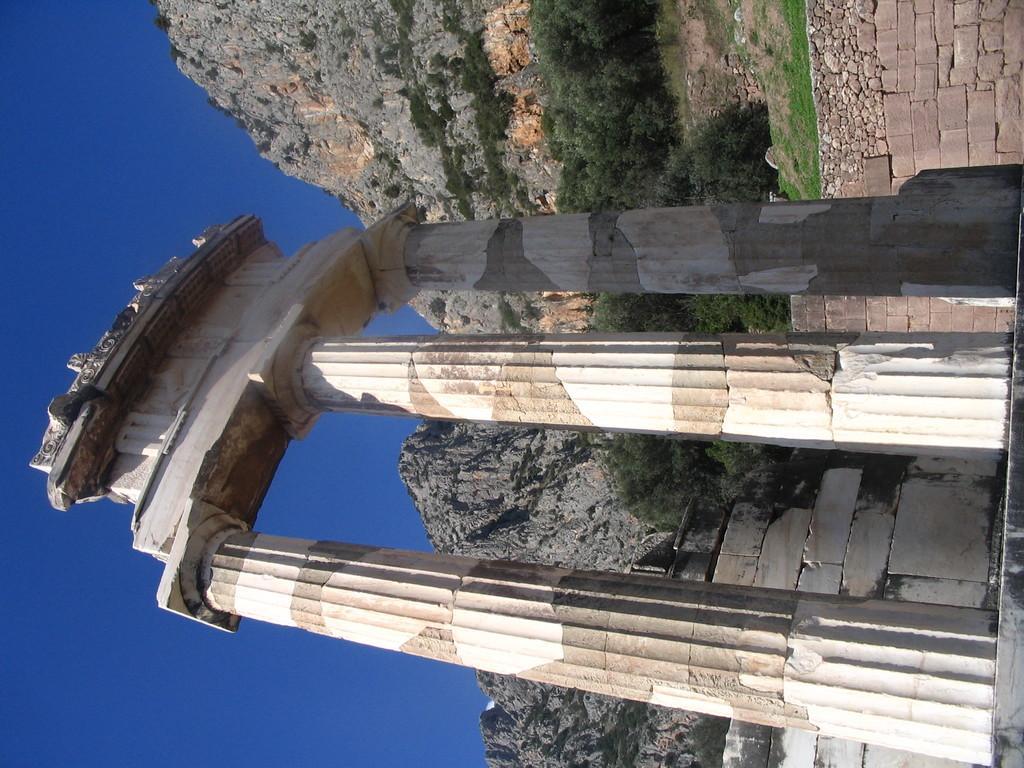Please provide a concise description of this image. In the foreground of this image, there is an architecture with pillars. In the background, there are mountains, trees, wall and the sky. 